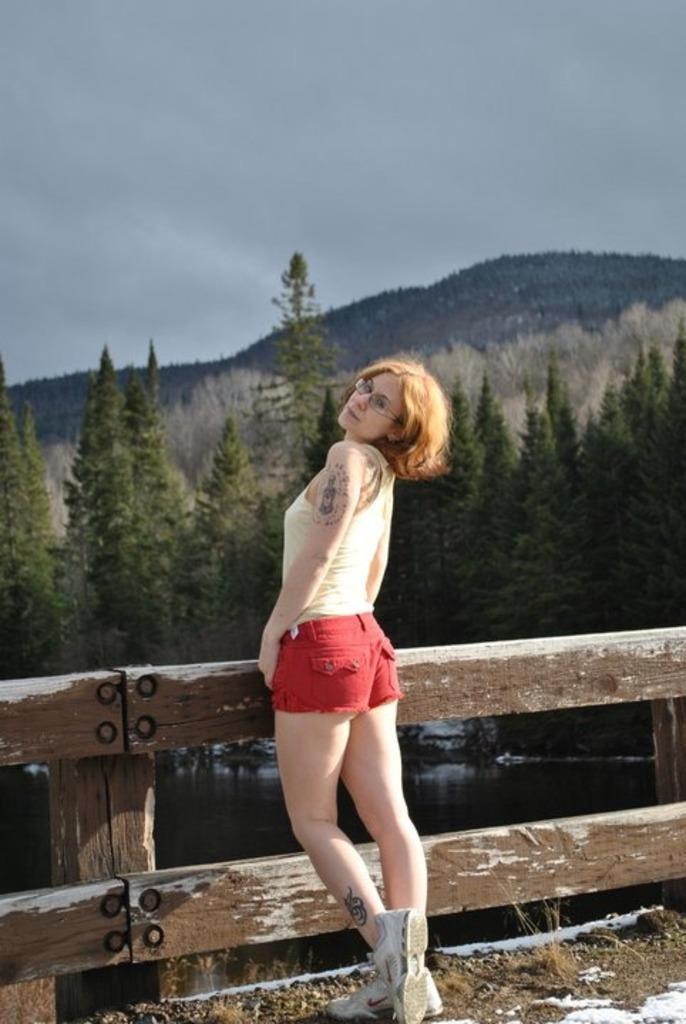In one or two sentences, can you explain what this image depicts? In this image there is a woman standing. Behind her there is a wooden fence. Behind the fence where is the water. In the background there are trees and mountains. At the top there is the sky. At the bottom there is snow on the ground. 